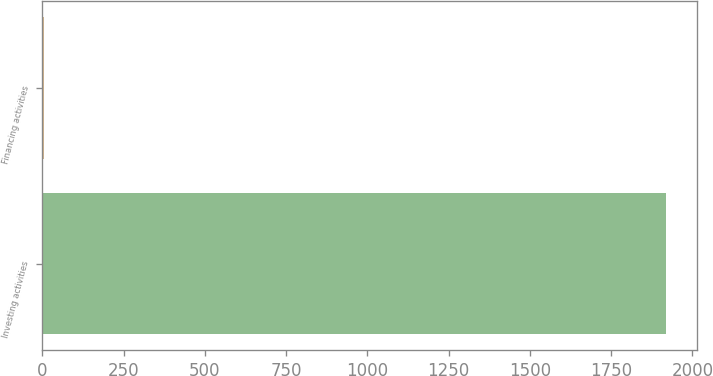Convert chart. <chart><loc_0><loc_0><loc_500><loc_500><bar_chart><fcel>Investing activities<fcel>Financing activities<nl><fcel>1919<fcel>6<nl></chart> 